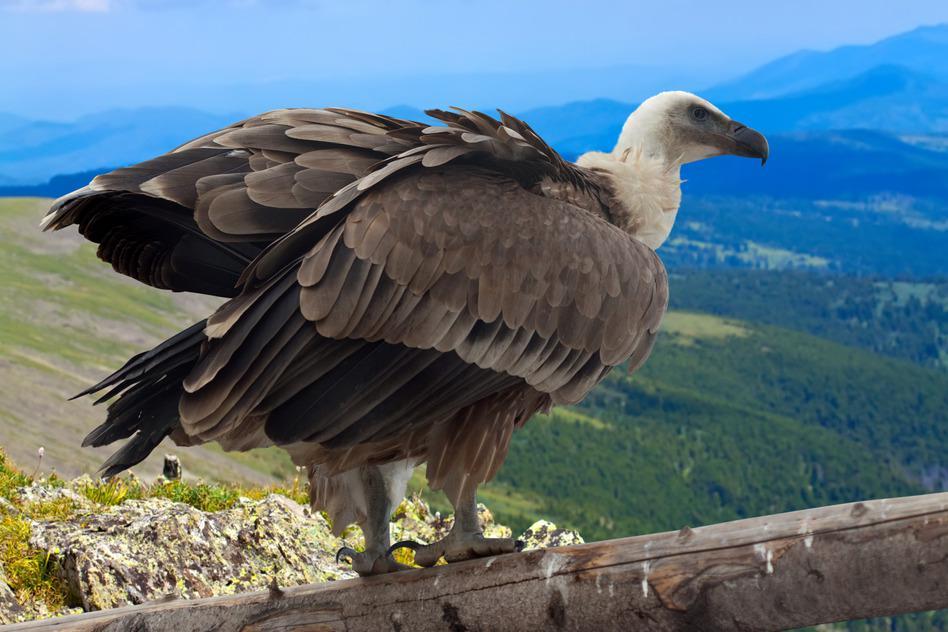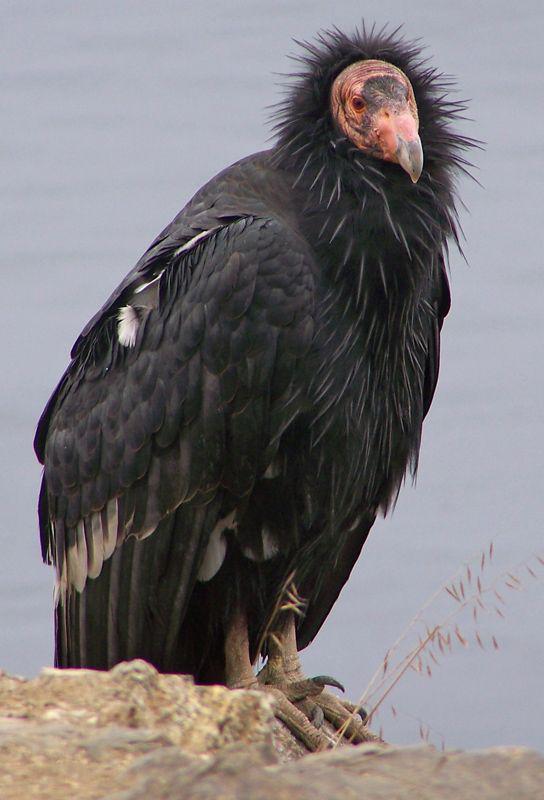The first image is the image on the left, the second image is the image on the right. For the images displayed, is the sentence "The vulture on the left has a white neck and brown wings." factually correct? Answer yes or no. Yes. 